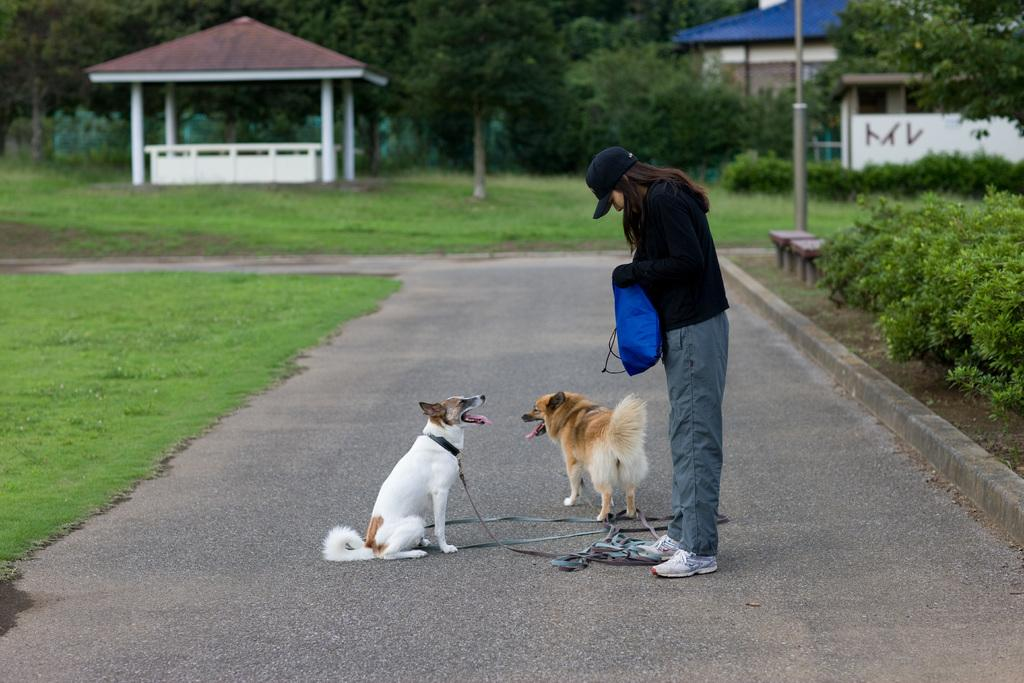How many dogs are in the image? There are two dogs in the image. What is the woman doing in the image? The woman is standing in the image. Where is the woman standing? The woman is standing on the road. What type of vegetation is visible in the image? Grass is visible in the image. What can be seen in the background of the image? There are buildings and trees in the background of the image. What other object is present in the image? There is a pole in the image. What type of quartz can be seen on the woman's necklace in the image? There is no quartz or necklace visible in the image. How does the jelly interact with the dogs in the image? There is no jelly present in the image, so it cannot interact with the dogs. 